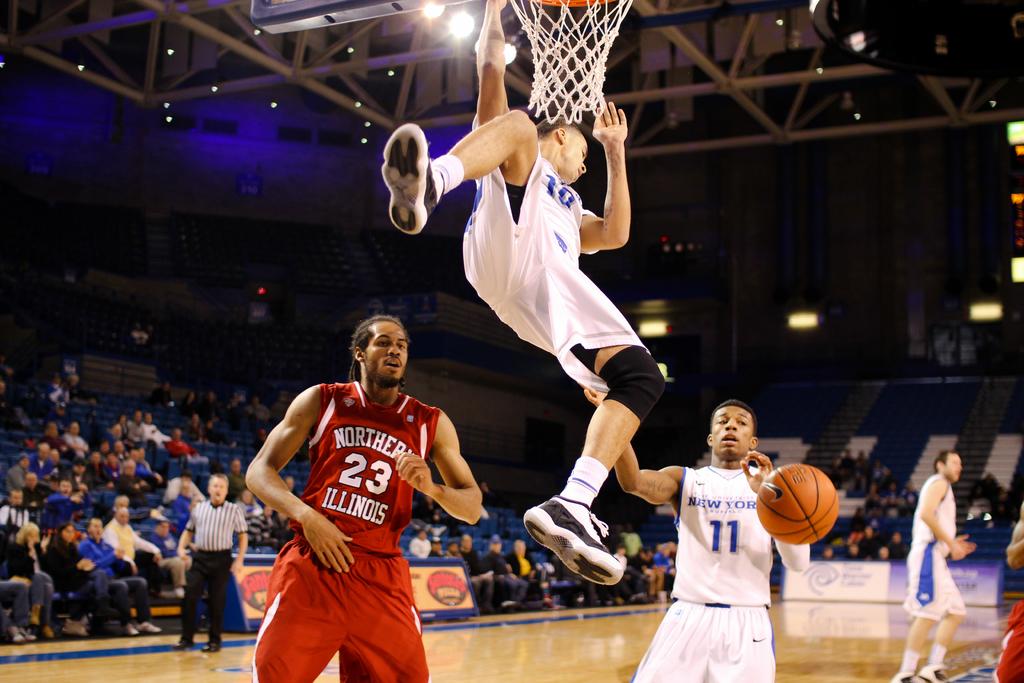What shirt number is the player on the left in red wearing?
Offer a terse response. 23. What sport is being played?
Keep it short and to the point. Basketball. 